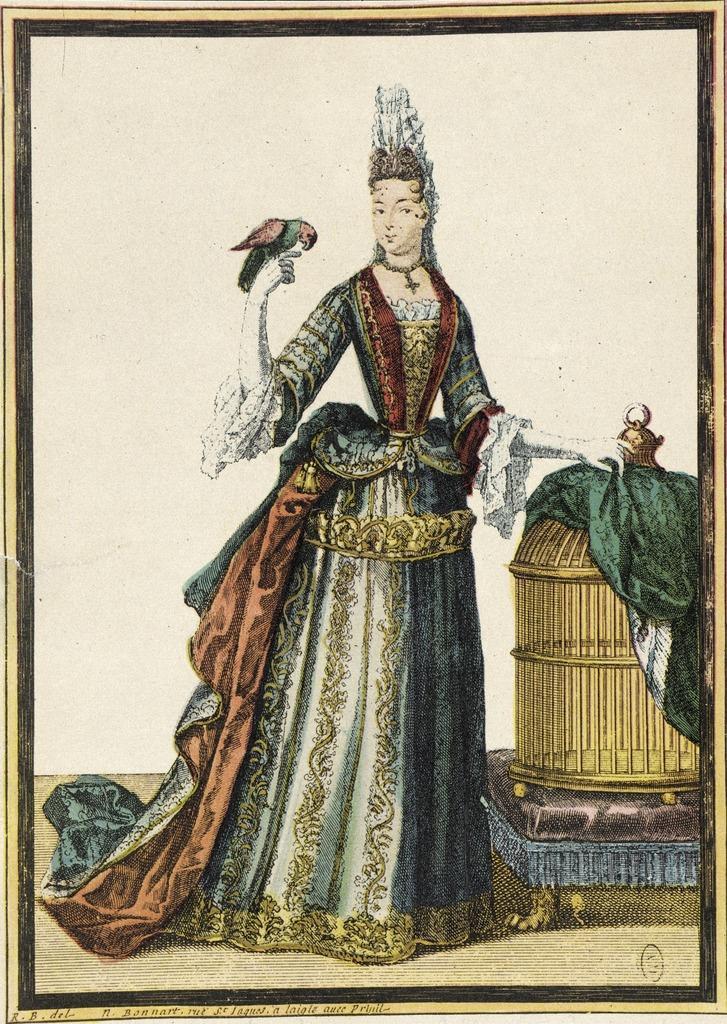Can you describe this image briefly? In this image I can see there is a painted picture. And there is a stool on the stool there is a cage where we can keep parrots in it and in the cage there is a cloth. And the person is holding a parrot. 